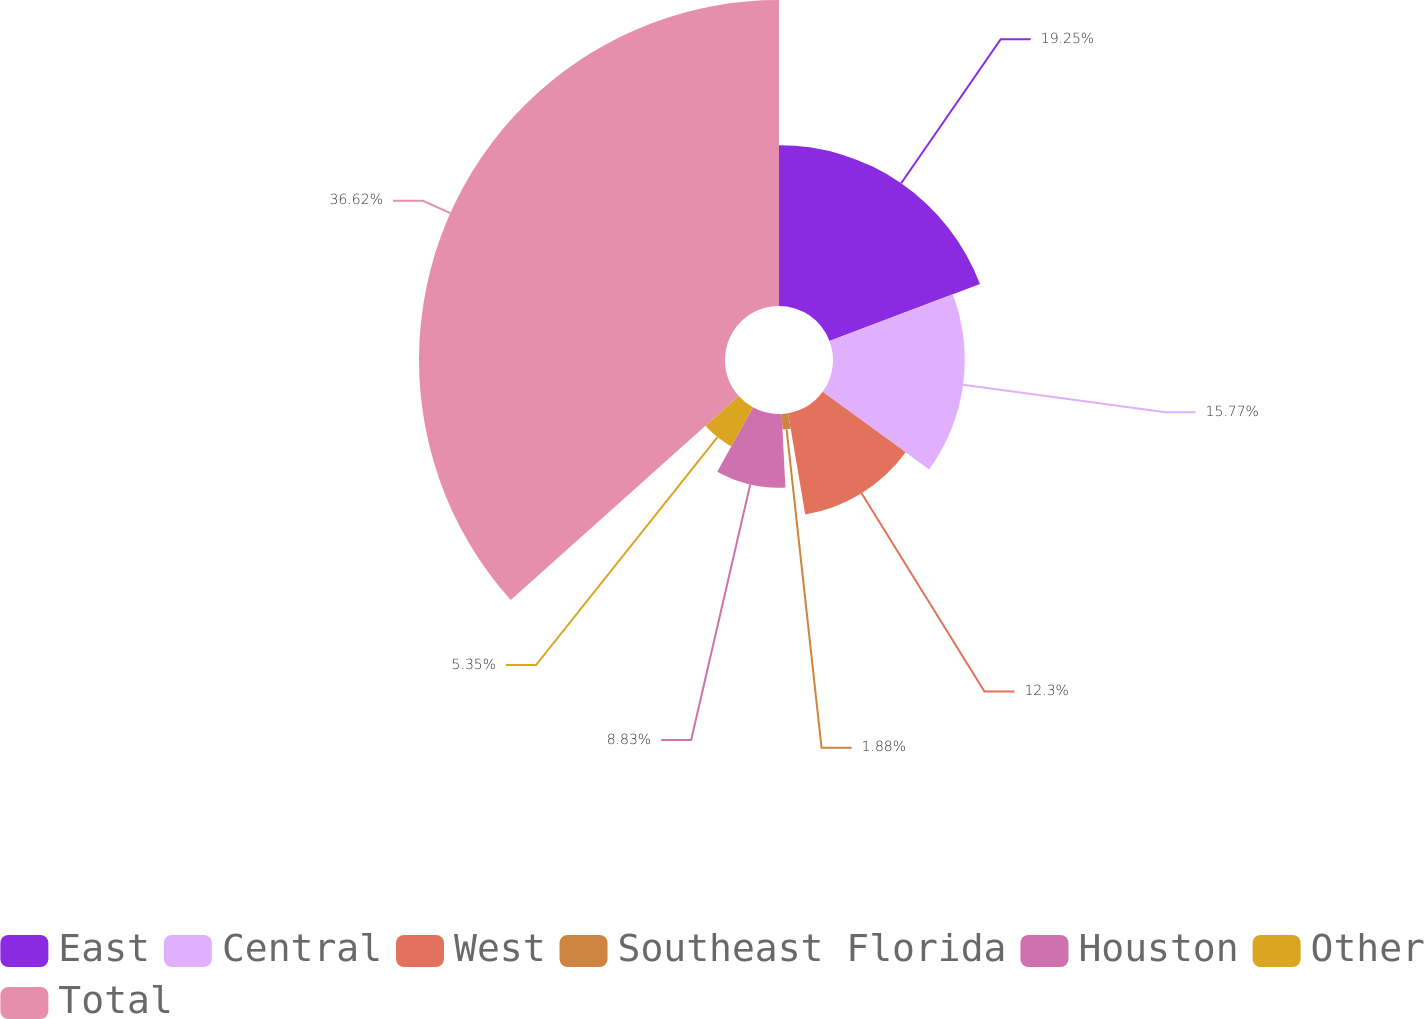Convert chart. <chart><loc_0><loc_0><loc_500><loc_500><pie_chart><fcel>East<fcel>Central<fcel>West<fcel>Southeast Florida<fcel>Houston<fcel>Other<fcel>Total<nl><fcel>19.25%<fcel>15.77%<fcel>12.3%<fcel>1.88%<fcel>8.83%<fcel>5.35%<fcel>36.62%<nl></chart> 